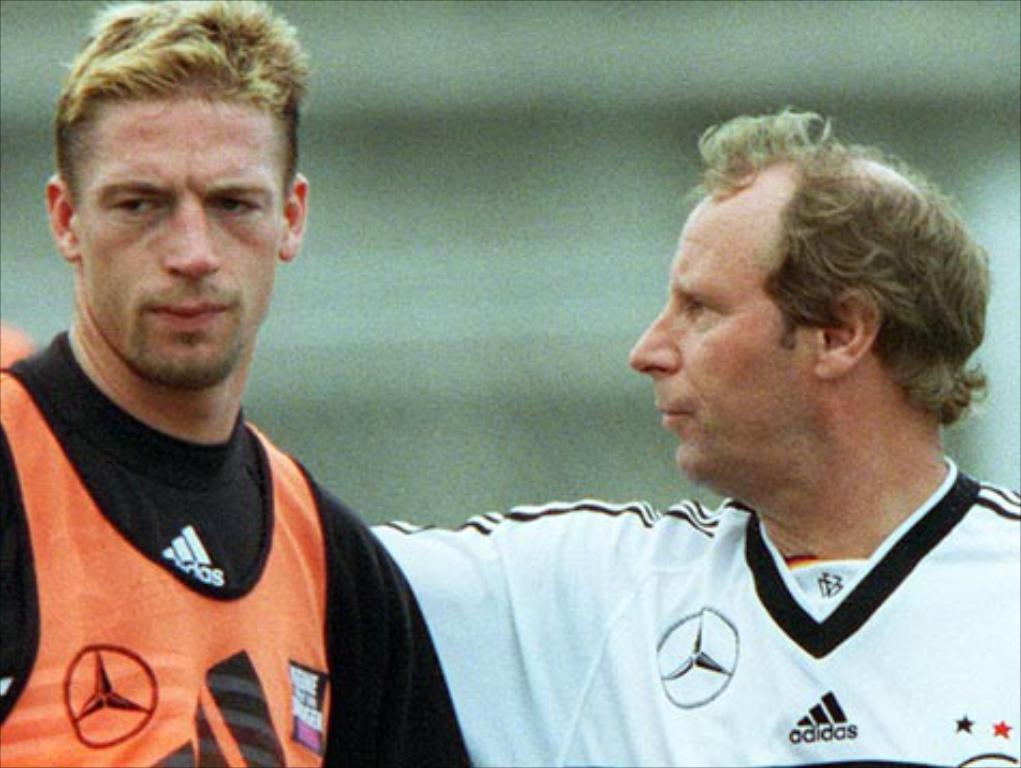What brand of clothing is the shirt?
Give a very brief answer. Adidas. 